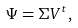<formula> <loc_0><loc_0><loc_500><loc_500>\Psi = \Sigma V ^ { t } ,</formula> 